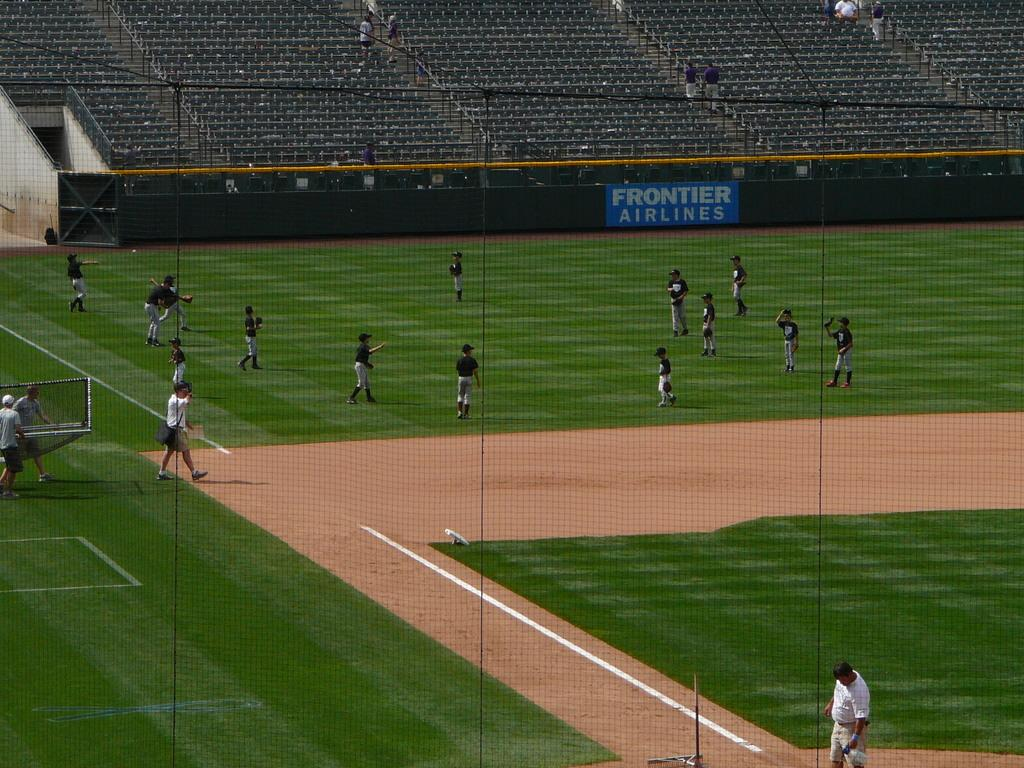<image>
Provide a brief description of the given image. People playing baseball on a field with a blue sign that says "Frontier Airlines". 